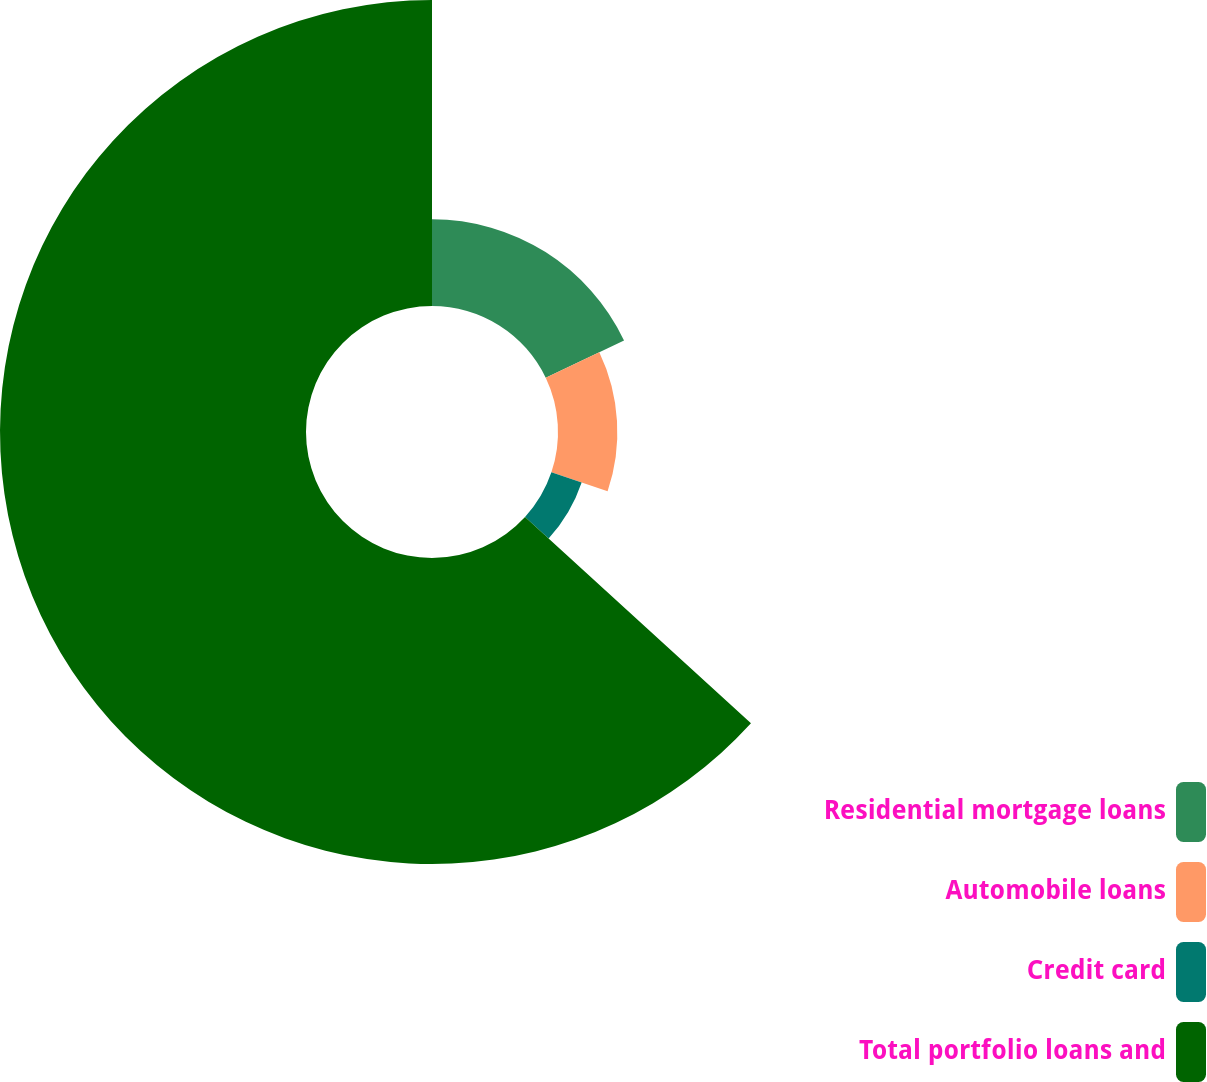Convert chart to OTSL. <chart><loc_0><loc_0><loc_500><loc_500><pie_chart><fcel>Residential mortgage loans<fcel>Automobile loans<fcel>Credit card<fcel>Total portfolio loans and<nl><fcel>17.92%<fcel>12.26%<fcel>6.6%<fcel>63.22%<nl></chart> 